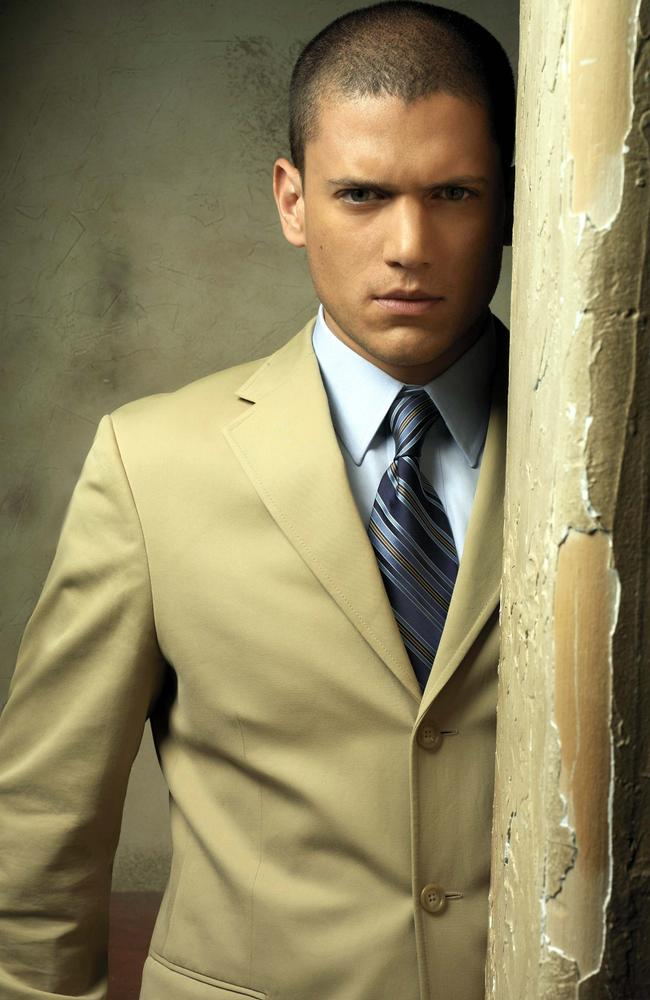Create a poetic description of the image. In the quiet solemnity of an age-old room,
A man stands, his presence dispelling the gloom.
Draped in beige, tie striped with hues of blue,
History whispers from walls, peeling, old yet true.
Gaze intense, a story etched in his eyes,
Between the cracks of time, a spirit that defies.
Here contrasts meet, modern and bygone intertwine,
In shadows and light, tales ancient and new combine. 